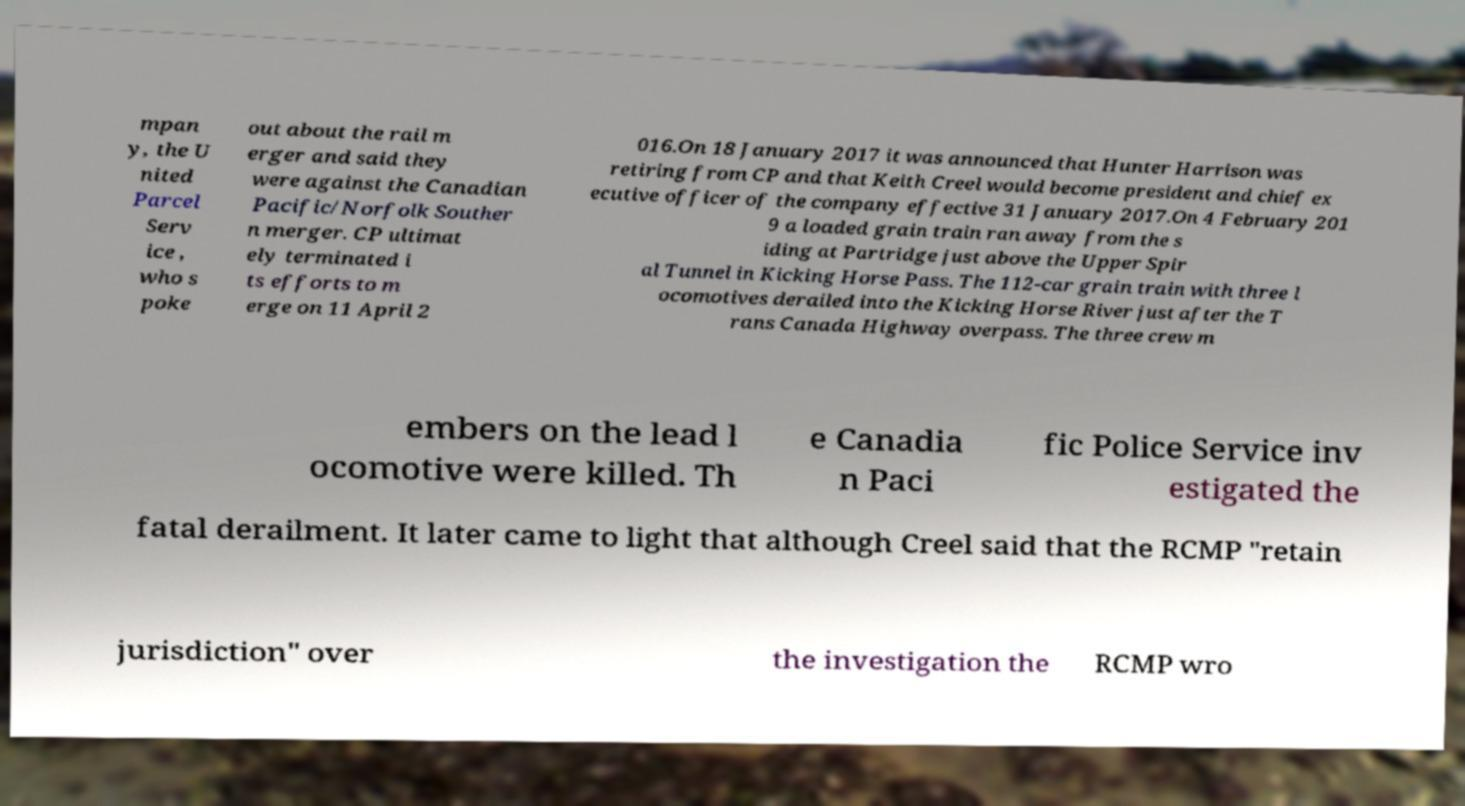For documentation purposes, I need the text within this image transcribed. Could you provide that? mpan y, the U nited Parcel Serv ice , who s poke out about the rail m erger and said they were against the Canadian Pacific/Norfolk Souther n merger. CP ultimat ely terminated i ts efforts to m erge on 11 April 2 016.On 18 January 2017 it was announced that Hunter Harrison was retiring from CP and that Keith Creel would become president and chief ex ecutive officer of the company effective 31 January 2017.On 4 February 201 9 a loaded grain train ran away from the s iding at Partridge just above the Upper Spir al Tunnel in Kicking Horse Pass. The 112-car grain train with three l ocomotives derailed into the Kicking Horse River just after the T rans Canada Highway overpass. The three crew m embers on the lead l ocomotive were killed. Th e Canadia n Paci fic Police Service inv estigated the fatal derailment. It later came to light that although Creel said that the RCMP "retain jurisdiction" over the investigation the RCMP wro 